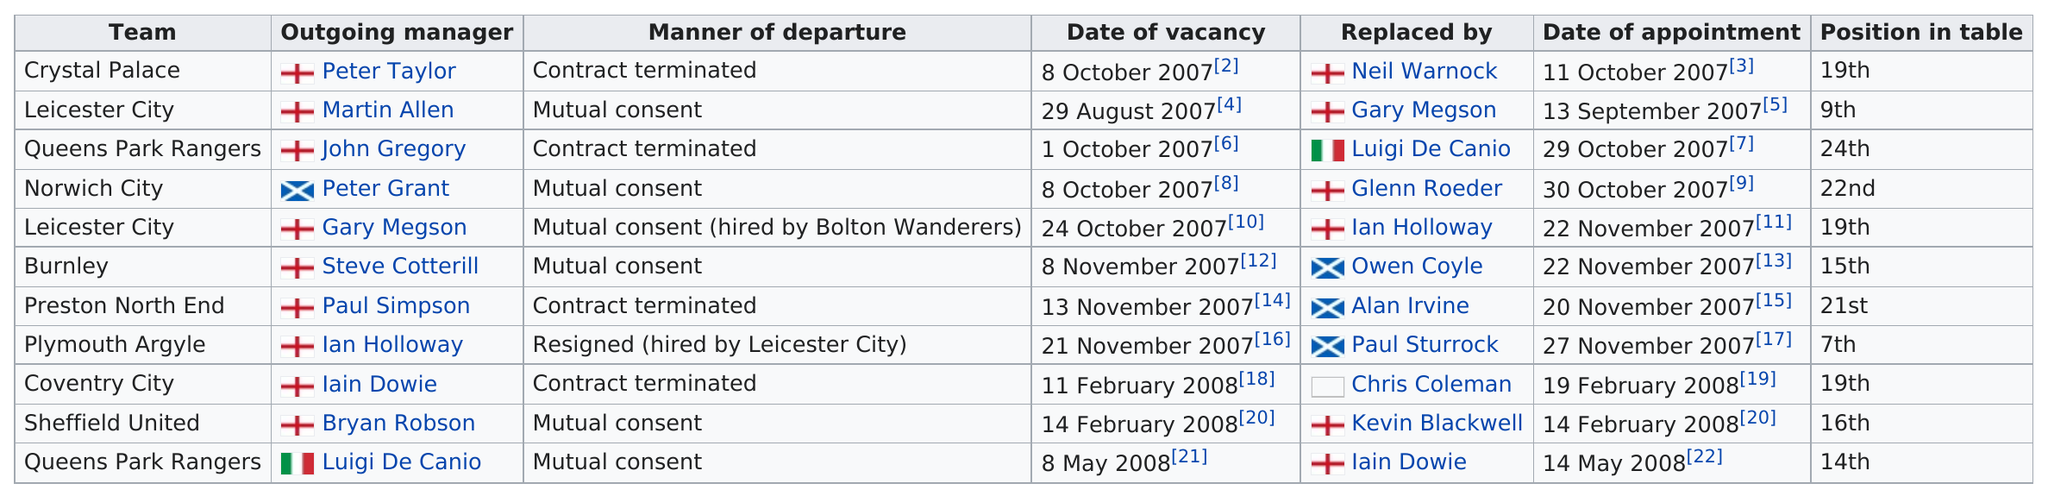Give some essential details in this illustration. During the 2007-08 football league championship season, there were more managers who left through mutual consent than those who were fired. The total number of times "mutual consent" is listed as the manner of departure is six. Ian Holloway is the only manager in history to have resigned from his position. Ian Holloway left Plymouth Argyle by resigning and subsequently being hired by Leicester City. The date of the appointment was in the month of November four times. 